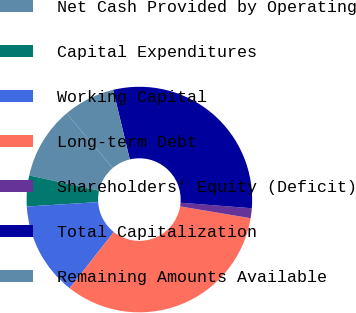Convert chart. <chart><loc_0><loc_0><loc_500><loc_500><pie_chart><fcel>Net Cash Provided by Operating<fcel>Capital Expenditures<fcel>Working Capital<fcel>Long-term Debt<fcel>Shareholders' Equity (Deficit)<fcel>Total Capitalization<fcel>Remaining Amounts Available<nl><fcel>10.41%<fcel>4.42%<fcel>13.41%<fcel>32.96%<fcel>1.42%<fcel>29.96%<fcel>7.42%<nl></chart> 